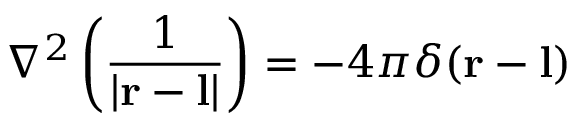<formula> <loc_0><loc_0><loc_500><loc_500>\nabla ^ { 2 } \left ( { \frac { 1 } { | r - l | } } \right ) = - 4 \pi \delta ( r - l )</formula> 